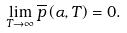<formula> <loc_0><loc_0><loc_500><loc_500>\lim _ { T \rightarrow \infty } \overline { p } \left ( \alpha , T \right ) = 0 .</formula> 